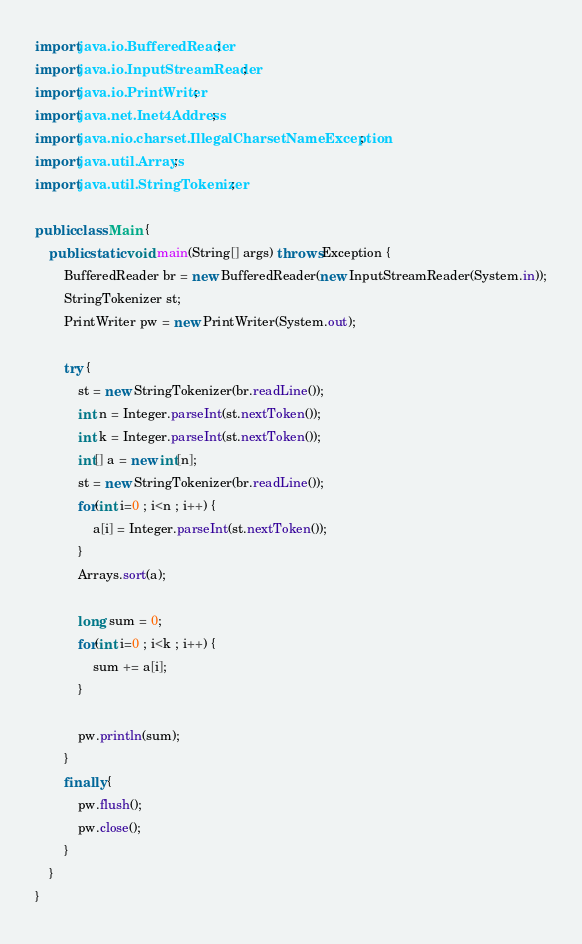Convert code to text. <code><loc_0><loc_0><loc_500><loc_500><_Java_>import java.io.BufferedReader;
import java.io.InputStreamReader;
import java.io.PrintWriter;
import java.net.Inet4Address;
import java.nio.charset.IllegalCharsetNameException;
import java.util.Arrays;
import java.util.StringTokenizer;

public class Main {
    public static void main(String[] args) throws Exception {
        BufferedReader br = new BufferedReader(new InputStreamReader(System.in));
        StringTokenizer st;
        PrintWriter pw = new PrintWriter(System.out);
        
        try {
            st = new StringTokenizer(br.readLine());
            int n = Integer.parseInt(st.nextToken());
            int k = Integer.parseInt(st.nextToken());
            int[] a = new int[n];
            st = new StringTokenizer(br.readLine());
            for(int i=0 ; i<n ; i++) {
                a[i] = Integer.parseInt(st.nextToken());
            }
            Arrays.sort(a);
            
            long sum = 0;
            for(int i=0 ; i<k ; i++) {
                sum += a[i];
            }
            
            pw.println(sum);
        }
        finally {
            pw.flush();
            pw.close();
        }
    }
}

</code> 